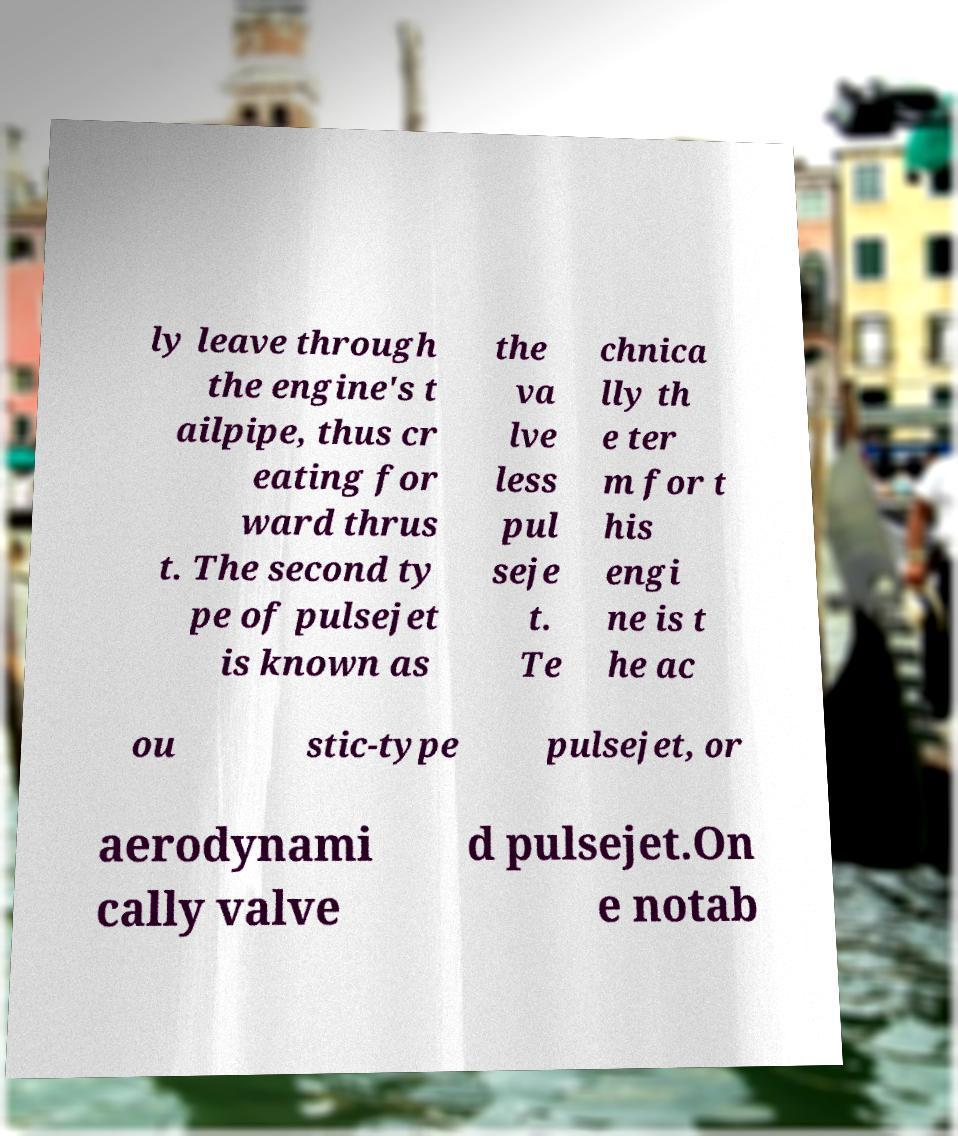Can you accurately transcribe the text from the provided image for me? ly leave through the engine's t ailpipe, thus cr eating for ward thrus t. The second ty pe of pulsejet is known as the va lve less pul seje t. Te chnica lly th e ter m for t his engi ne is t he ac ou stic-type pulsejet, or aerodynami cally valve d pulsejet.On e notab 